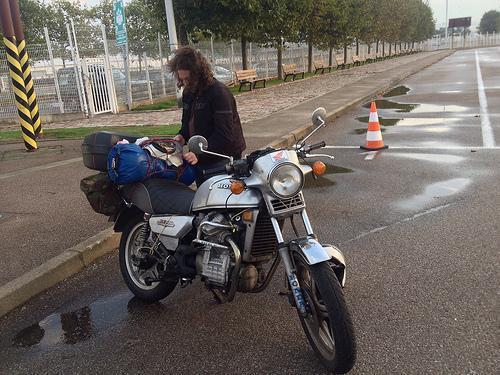How many motorcycles are there?
Give a very brief answer. 1. How many wheels on the vehicle?
Give a very brief answer. 2. How many cones are on the sidewalk?
Give a very brief answer. 0. 